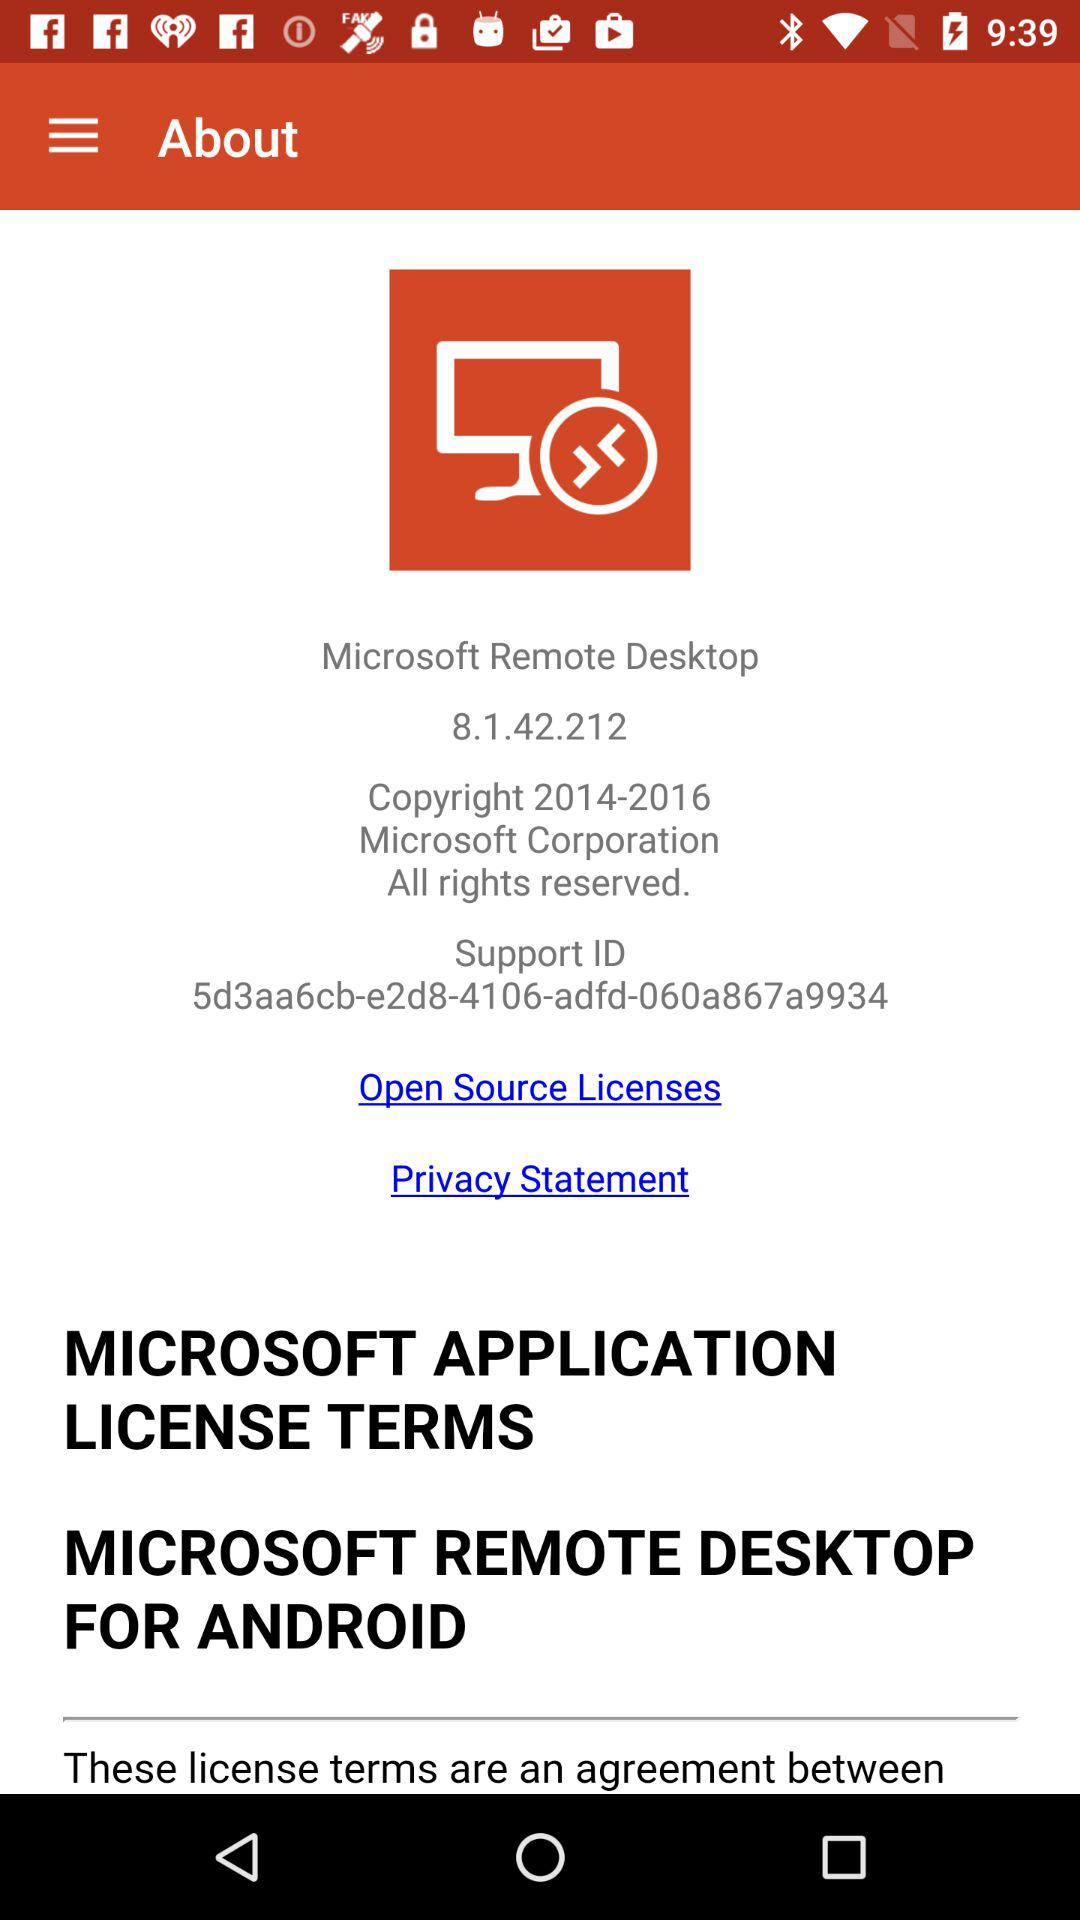What is the support ID? The support ID is 5d3aa6cb-e2d8-4106-adfd-060a867a9934. 